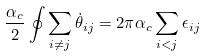<formula> <loc_0><loc_0><loc_500><loc_500>\frac { \alpha _ { c } } { 2 } \oint \sum _ { i \ne j } \dot { \theta } _ { i j } = 2 \pi \alpha _ { c } \sum _ { i < j } \epsilon _ { i j }</formula> 